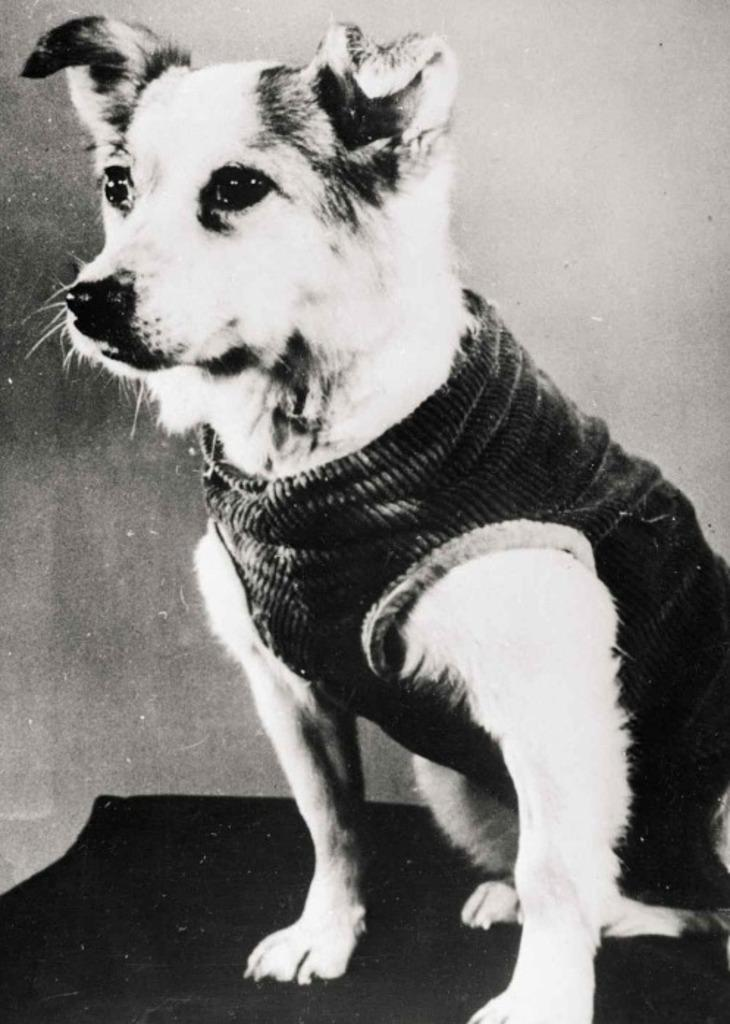What is the color scheme of the image? The image is black and white. What animal can be seen in the image? There is a dog in the image. What is visible in the background of the image? There is a wall in the background of the image. What type of love can be seen between the dog and the van in the image? There is no van present in the image, and therefore no interaction between the dog and a van can be observed. 